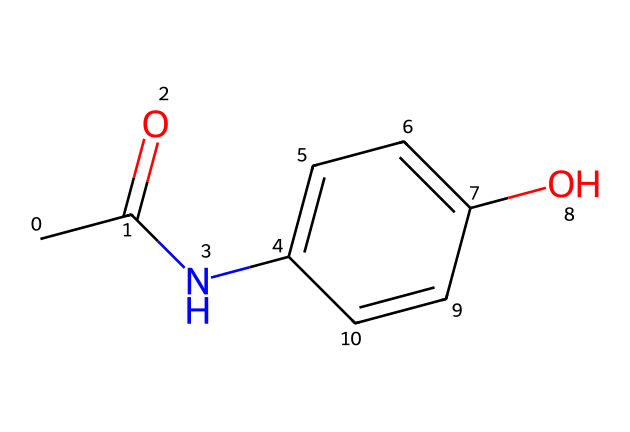what is the molecular formula of this compound? To determine the molecular formula, count the number of each type of atom present in the SMILES representation. In this case, the SMILES shows 8 carbon atoms (C), 9 hydrogen atoms (H), 1 nitrogen atom (N), and 2 oxygen atoms (O). Therefore, the molecular formula is C8H9NO2.
Answer: C8H9NO2 how many rings are present in the structure? A careful examination of the SMILES representation indicates that there are no ring structures present; acetaminophen has a simple, linear arrangement of atoms without cyclic components. Thus, the total number of rings is zero.
Answer: 0 what type of functional groups are present in acetaminophen? Analyzing the structure reveals two functional groups: an amide group (due to the -NH and carbonyl) and a hydroxyl group (since there is an -OH group). These groups are crucial for the compound's medicinal activity.
Answer: amide and hydroxyl how does the presence of the hydroxyl group affect solubility? The hydroxyl group (-OH) forms hydrogen bonds with water molecules, making acetaminophen more soluble in water compared to non-polar compounds. This polar functional group increases overall solubility due to its ability to interact with the aqueous environment.
Answer: increases solubility what is the significance of the acetyl group in this compound? The acetyl group (CC(=O)-) is essential in defining the compound's properties, contributing to its pain-relieving effects. Moreover, it activates the compound, making it more effective as a pain reliever by influencing its metabolic pathways.
Answer: pain relief effectiveness how many hydrogen bonds can acetaminophen potentially form? The structure indicates the presence of one hydroxyl group and one amide nitrogen that can act as hydrogen bond donors; thus, it can form multiple hydrogen bonds with solvent molecules or other compounds, but count primarily two (one from -NH and one from -OH).
Answer: two 